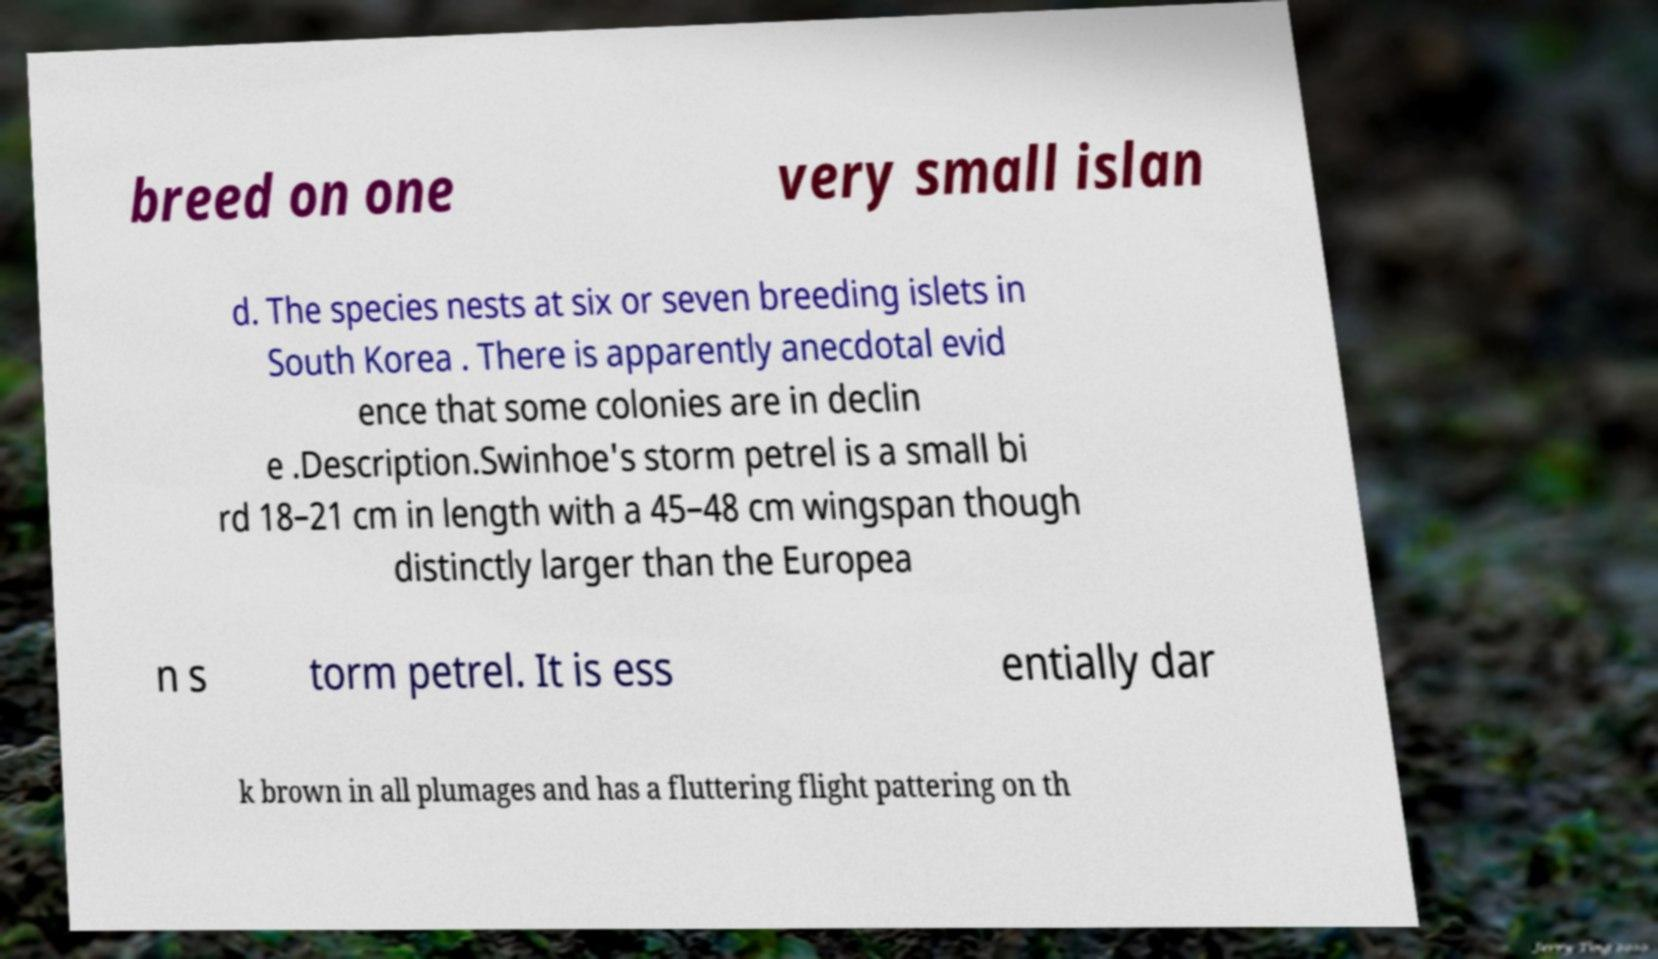What messages or text are displayed in this image? I need them in a readable, typed format. breed on one very small islan d. The species nests at six or seven breeding islets in South Korea . There is apparently anecdotal evid ence that some colonies are in declin e .Description.Swinhoe's storm petrel is a small bi rd 18–21 cm in length with a 45–48 cm wingspan though distinctly larger than the Europea n s torm petrel. It is ess entially dar k brown in all plumages and has a fluttering flight pattering on th 